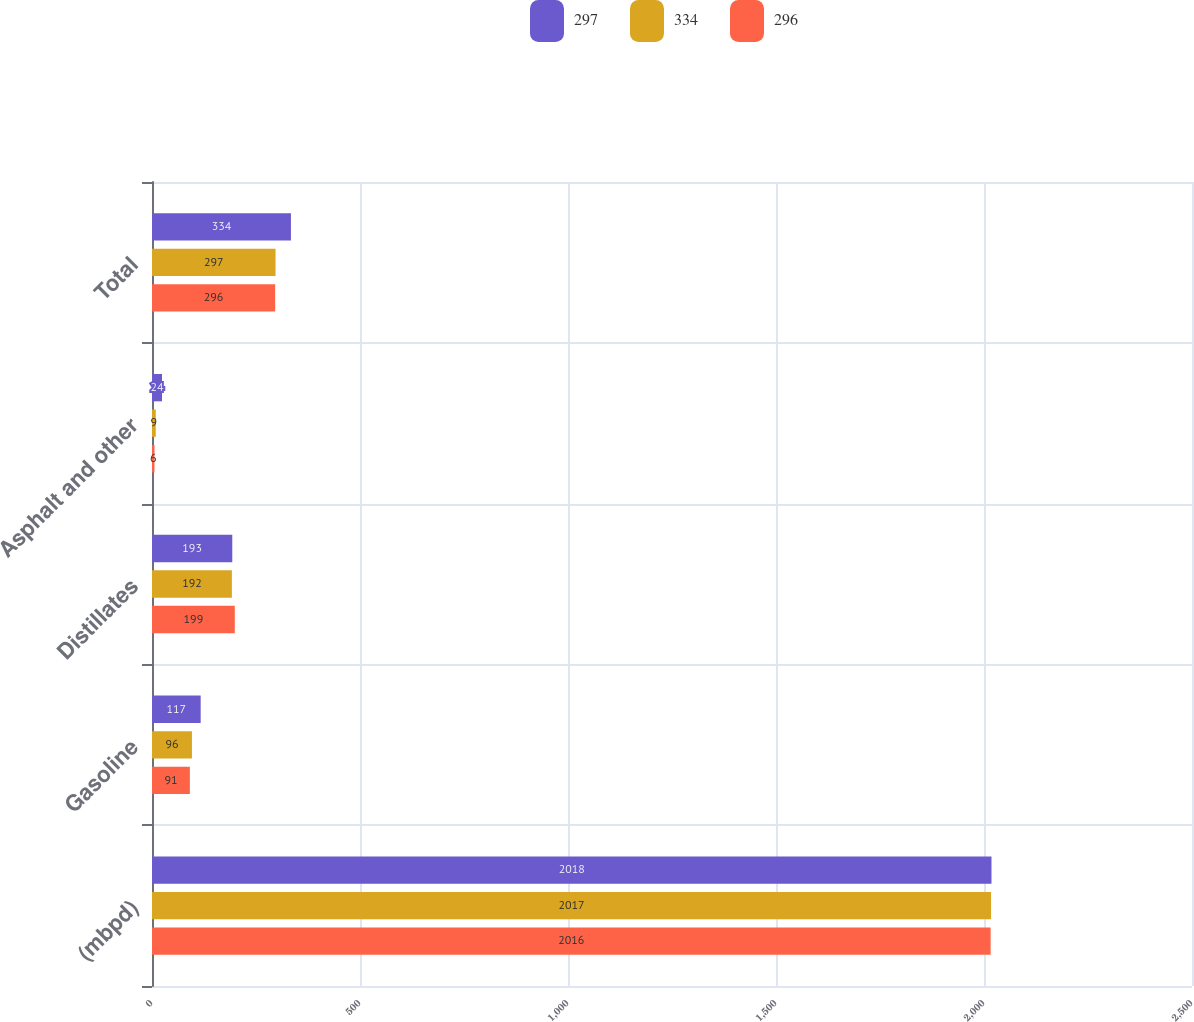Convert chart. <chart><loc_0><loc_0><loc_500><loc_500><stacked_bar_chart><ecel><fcel>(mbpd)<fcel>Gasoline<fcel>Distillates<fcel>Asphalt and other<fcel>Total<nl><fcel>297<fcel>2018<fcel>117<fcel>193<fcel>24<fcel>334<nl><fcel>334<fcel>2017<fcel>96<fcel>192<fcel>9<fcel>297<nl><fcel>296<fcel>2016<fcel>91<fcel>199<fcel>6<fcel>296<nl></chart> 